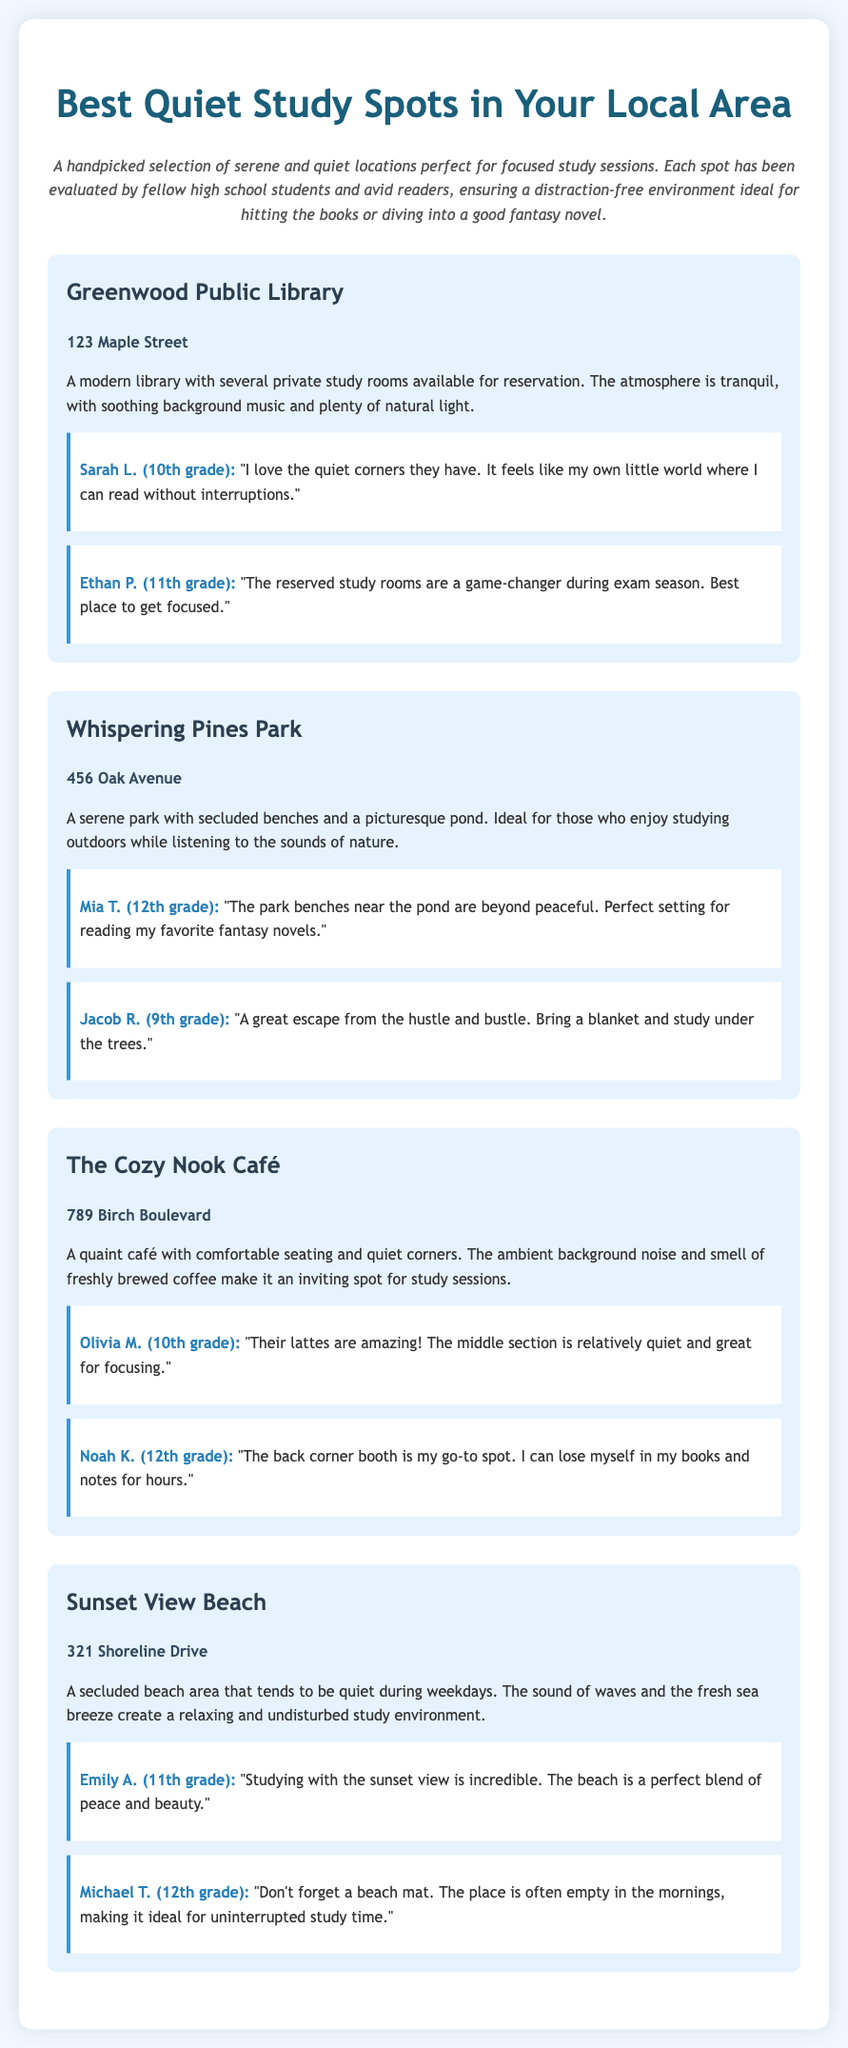What is the address of Greenwood Public Library? The address of Greenwood Public Library is listed in the document.
Answer: 123 Maple Street How many reviews are there for The Cozy Nook Café? The number of reviews can be counted in the section for The Cozy Nook Café.
Answer: 2 Which study spot offers reserved study rooms? This can be found in the description of one of the study spots.
Answer: Greenwood Public Library What is the main feature of Sunset View Beach? The main feature is indicated in the document regarding its environment.
Answer: Secluded beach Who is the reviewer that mentioned the park benches near the pond? This can be identified in the reviews for Whispering Pines Park.
Answer: Mia T. (12th grade) What kind of beverage is highlighted in the reviews for The Cozy Nook Café? The beverage mentioned in the review helps identify a specific offering at the café.
Answer: Lattes Which study spot is located on Shoreline Drive? This information can be found by referencing the address in the study spot section.
Answer: Sunset View Beach What is the atmosphere described for Whispering Pines Park? The atmosphere can be inferred from the description given for this study spot.
Answer: Serene 